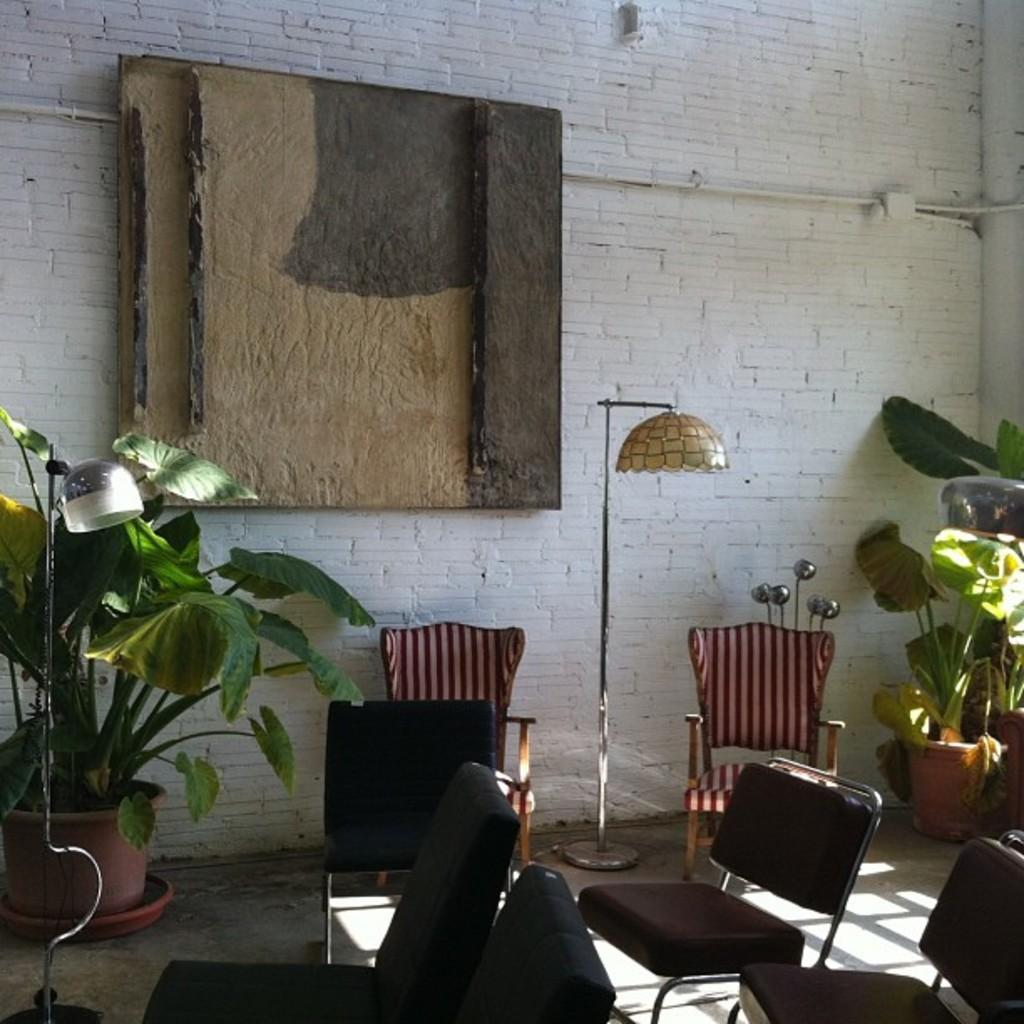Can you describe this image briefly? Plant there are chairs and lamp backside there is wall. 